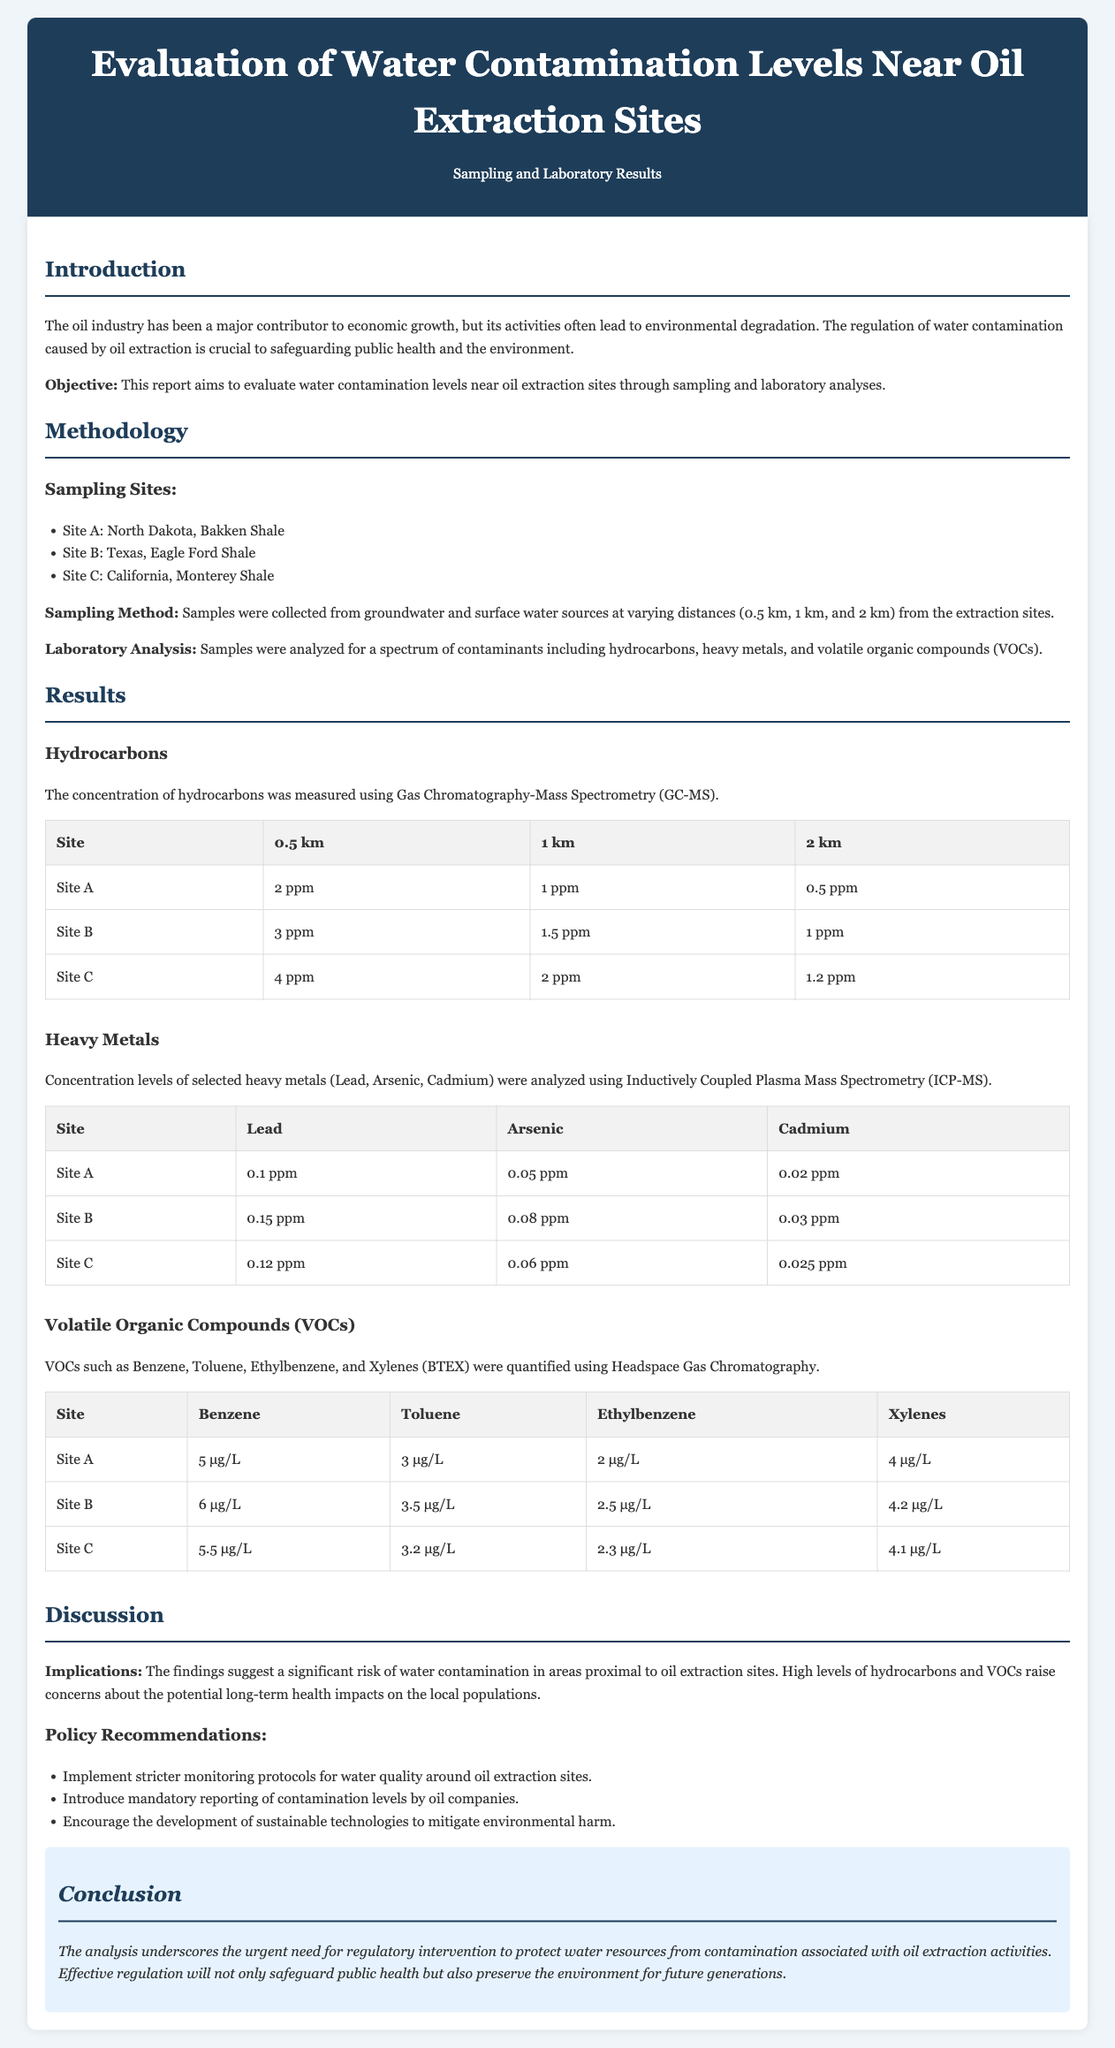What is the objective of the study? The objective of the study stated in the document is to evaluate water contamination levels near oil extraction sites through sampling and laboratory analyses.
Answer: Evaluate water contamination levels near oil extraction sites Which sampling site has the highest hydrocarbon concentration at 0.5 km? The document lists the hydrocarbon concentrations for each site and distance, with Site C having the highest concentration at 0.5 km.
Answer: Site C What is the concentration of Lead at Site B? The Lead concentration is listed specifically for each site in the heavy metals results table.
Answer: 0.15 ppm What methodology was used for VOC analysis? The document explicitly states the use of Headspace Gas Chromatography for quantifying VOCs.
Answer: Headspace Gas Chromatography Based on the findings, what is one key implication mentioned? The document discusses significant risks associated with high levels of hydrocarbons and VOCs, emphasizing potential health impacts on local populations.
Answer: Significant risk of water contamination What recommendations are made for monitoring water quality? The recommendations section specifically states that stricter monitoring protocols should be implemented for water quality around oil extraction sites.
Answer: Implement stricter monitoring protocols Which heavy metal had the lowest concentration across all sites? The heavy metals section provides the concentration levels for Lead, Arsenic, and Cadmium, with Cadmium being the lowest overall.
Answer: Cadmium How many km were the samples collected from the extraction sites? The document indicates that samples were collected at varying distances, specifically at 0.5 km, 1 km, and 2 km.
Answer: 0.5 km, 1 km, and 2 km 